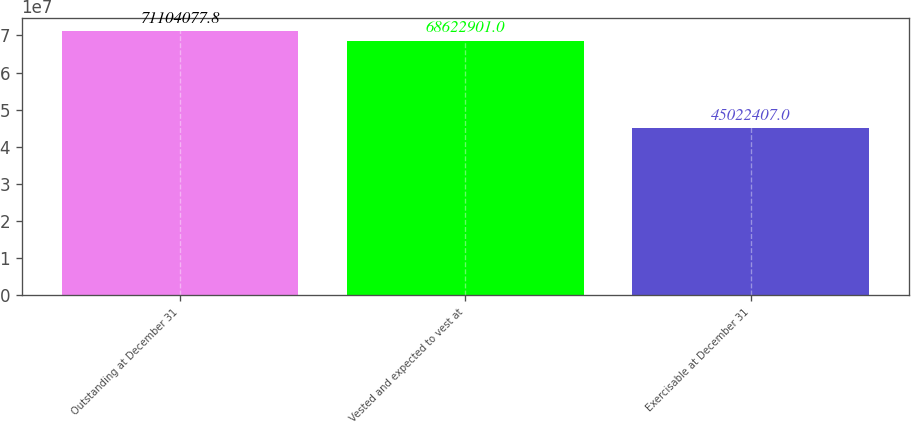Convert chart. <chart><loc_0><loc_0><loc_500><loc_500><bar_chart><fcel>Outstanding at December 31<fcel>Vested and expected to vest at<fcel>Exercisable at December 31<nl><fcel>7.11041e+07<fcel>6.86229e+07<fcel>4.50224e+07<nl></chart> 